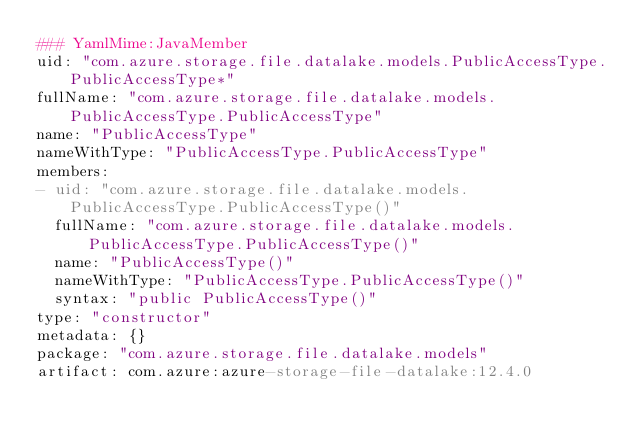Convert code to text. <code><loc_0><loc_0><loc_500><loc_500><_YAML_>### YamlMime:JavaMember
uid: "com.azure.storage.file.datalake.models.PublicAccessType.PublicAccessType*"
fullName: "com.azure.storage.file.datalake.models.PublicAccessType.PublicAccessType"
name: "PublicAccessType"
nameWithType: "PublicAccessType.PublicAccessType"
members:
- uid: "com.azure.storage.file.datalake.models.PublicAccessType.PublicAccessType()"
  fullName: "com.azure.storage.file.datalake.models.PublicAccessType.PublicAccessType()"
  name: "PublicAccessType()"
  nameWithType: "PublicAccessType.PublicAccessType()"
  syntax: "public PublicAccessType()"
type: "constructor"
metadata: {}
package: "com.azure.storage.file.datalake.models"
artifact: com.azure:azure-storage-file-datalake:12.4.0
</code> 